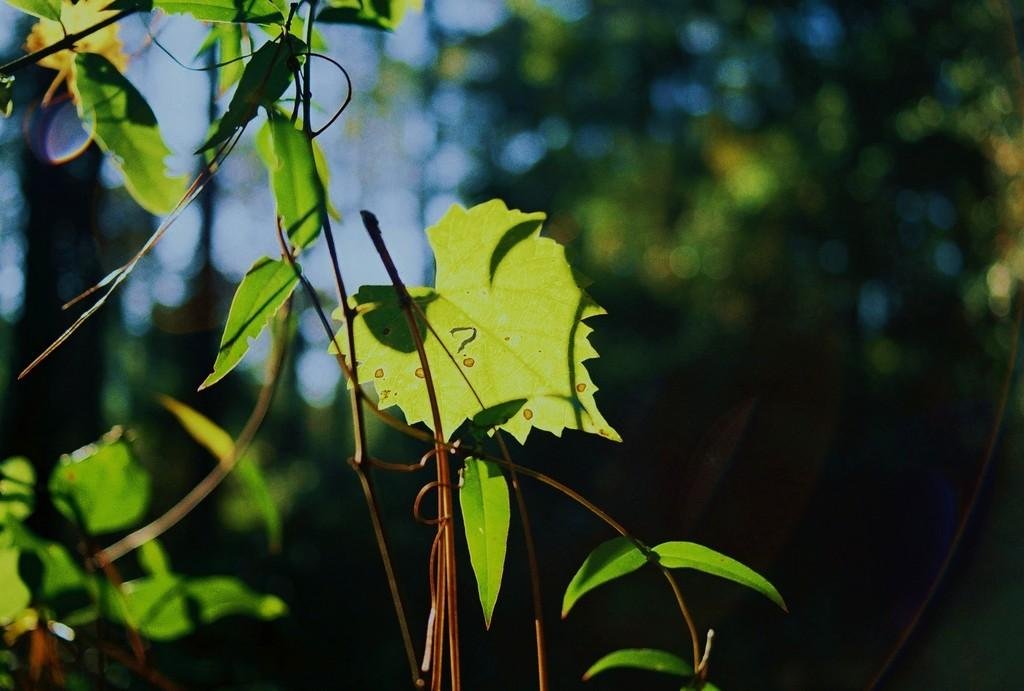What type of plant is visible in the image? There are green leaves with stems in the image. Can you describe the background of the image? The background of the image is blurred. Who is the owner of the pancake in the image? There is no pancake present in the image, so it is not possible to determine the owner. 